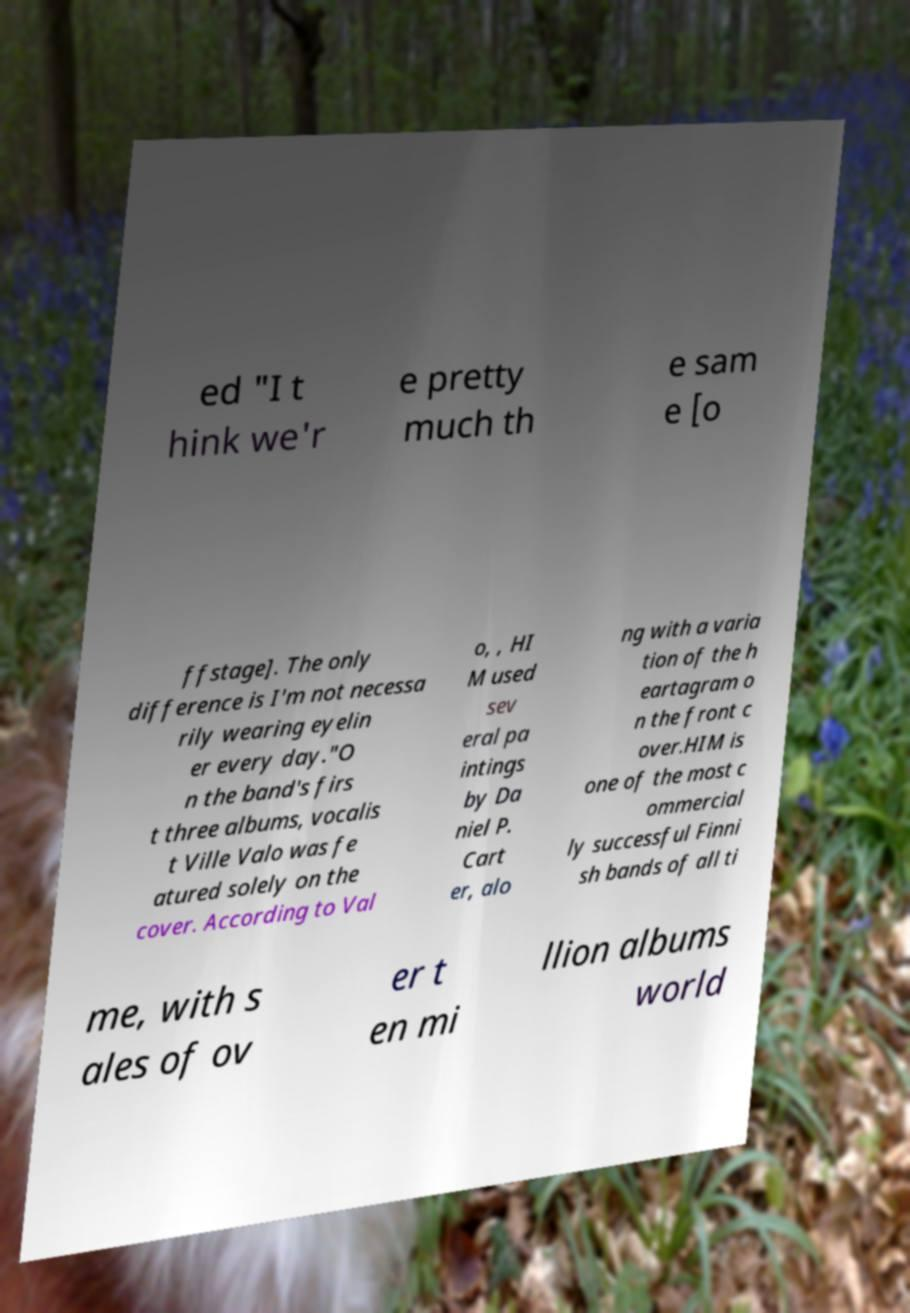Please identify and transcribe the text found in this image. ed "I t hink we'r e pretty much th e sam e [o ffstage]. The only difference is I'm not necessa rily wearing eyelin er every day."O n the band's firs t three albums, vocalis t Ville Valo was fe atured solely on the cover. According to Val o, , HI M used sev eral pa intings by Da niel P. Cart er, alo ng with a varia tion of the h eartagram o n the front c over.HIM is one of the most c ommercial ly successful Finni sh bands of all ti me, with s ales of ov er t en mi llion albums world 